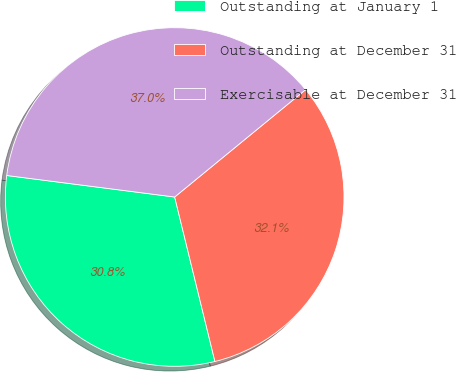Convert chart to OTSL. <chart><loc_0><loc_0><loc_500><loc_500><pie_chart><fcel>Outstanding at January 1<fcel>Outstanding at December 31<fcel>Exercisable at December 31<nl><fcel>30.85%<fcel>32.11%<fcel>37.04%<nl></chart> 